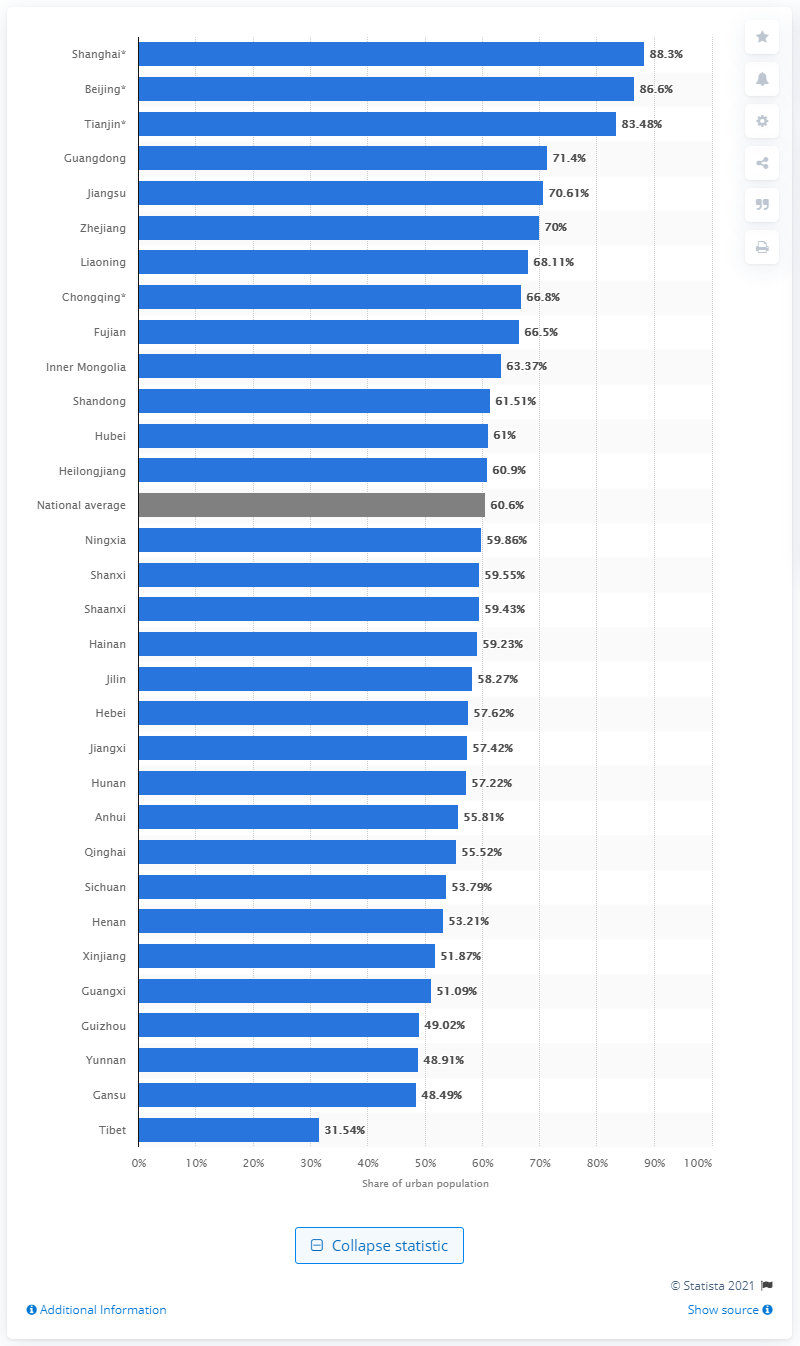Mention a couple of crucial points in this snapshot. In 2019, the national urbanization rate in China was 61%. The rate of urbanization in Tibet in 2019 was 31.54%. In 2019, the urbanization rate in Shanghai was 88.3%. 